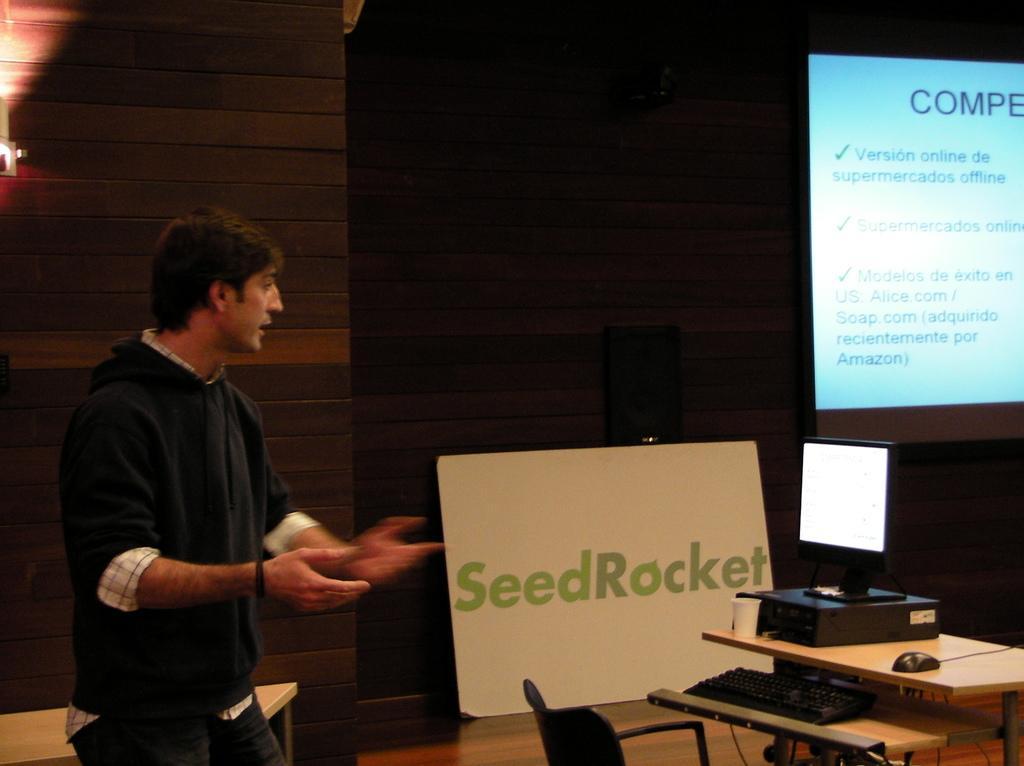In one or two sentences, can you explain what this image depicts? In this image, we can see a person is standing. Background we can see wall. On the right side of the image, there is a screen, monitor, box, table, keyboard, mouse and board. At the bottom, of the image, we can see chair, surface and table. Here we can see black objects. 